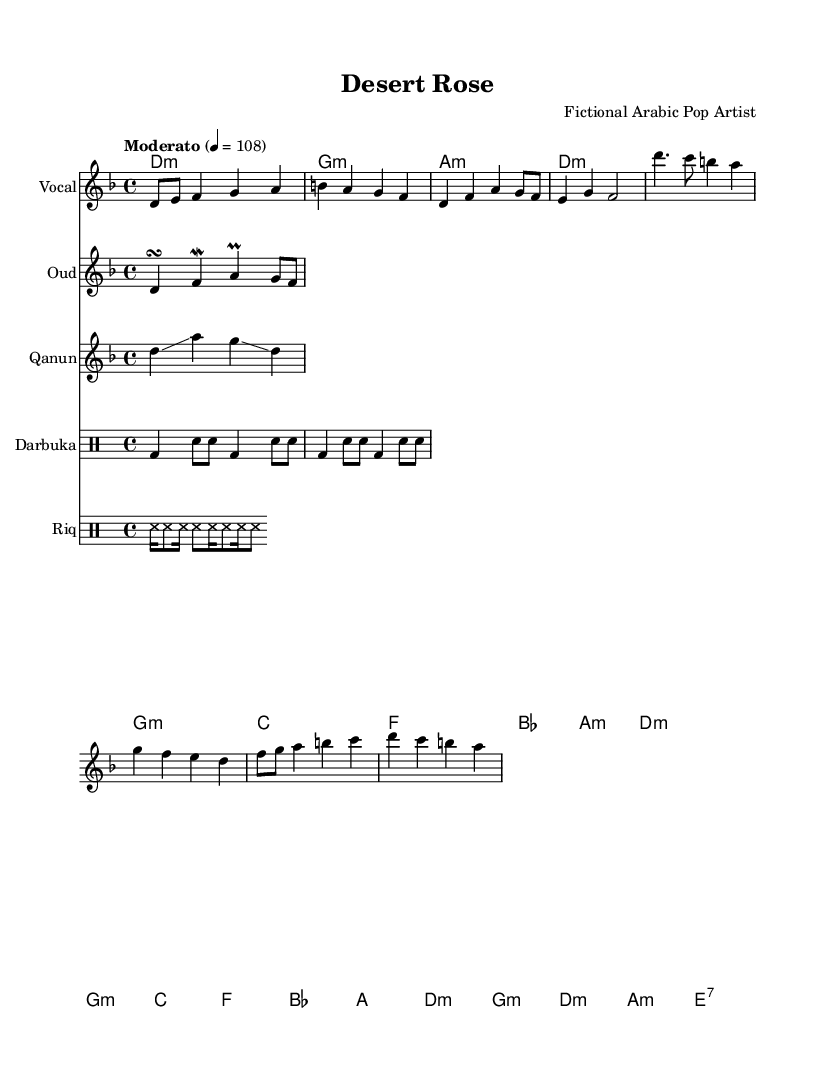What is the key signature of this music? The key signature is D minor, which has one flat (B♭) and is indicated at the beginning of the sheet music.
Answer: D minor What is the time signature of this music? The time signature is 4/4, which means there are four beats per measure and a quarter note gets one beat. It is also shown at the start of the sheet music.
Answer: 4/4 What is the tempo marking of the song? The tempo marking is "Moderato," which indicates a moderate pace typically between 108 beats per minute. This is shown at the beginning of the piece next to the metronome marking "4 = 108."
Answer: Moderato How many measures are in the introduction section? The introduction section contains 4 measures, which can be counted from the notes presented after the completion of the drum patterns. Each group of notes separated by a bar line represents one measure.
Answer: 4 What traditional instrument is used along with the vocal line? The traditional instrument used alongside the vocal line is the Oud, which is indicated by the staff labeled "Oud" below the vocal melody.
Answer: Oud In which section of the song do we see a modulation in instruments? The bridge section introduces the instruments with a different combination, specifically the Oud and Qanun, which play different melodic lines, indicating a transition in texture. This is noticeable in the part where the rhythms for the Darbuka and Riq change.
Answer: Bridge 